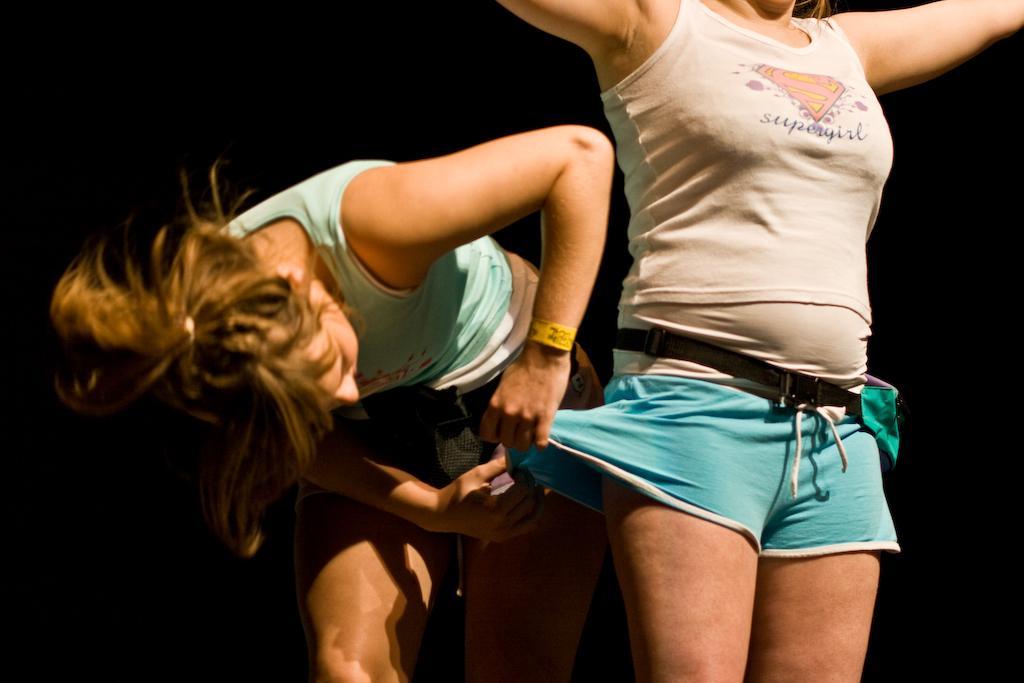Please provide a concise description of this image. In the image there are two women, one woman is standing and behind her another woman is adjusting her dress and the background of the woman is black. 